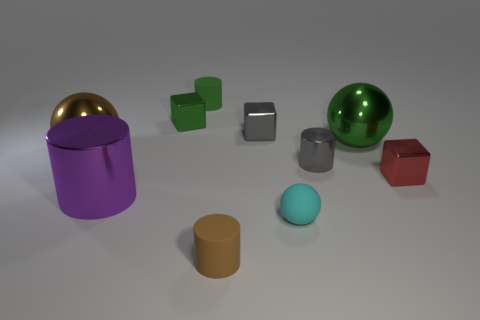What color is the cylinder that is the same material as the purple object?
Offer a terse response. Gray. How many cylinders are either cyan things or small green shiny things?
Make the answer very short. 0. What number of things are either tiny green metallic blocks or shiny blocks that are in front of the green cube?
Ensure brevity in your answer.  3. Are there any small red rubber cubes?
Your answer should be compact. No. How many small rubber objects have the same color as the matte sphere?
Give a very brief answer. 0. There is a block that is the same color as the small shiny cylinder; what material is it?
Keep it short and to the point. Metal. There is a brown thing in front of the large shiny sphere left of the large metallic cylinder; what is its size?
Ensure brevity in your answer.  Small. Is there a big brown cylinder that has the same material as the small brown thing?
Your response must be concise. No. There is a gray cylinder that is the same size as the cyan matte ball; what material is it?
Provide a short and direct response. Metal. Does the tiny shiny block in front of the big green shiny sphere have the same color as the big shiny sphere behind the big brown shiny thing?
Provide a succinct answer. No. 